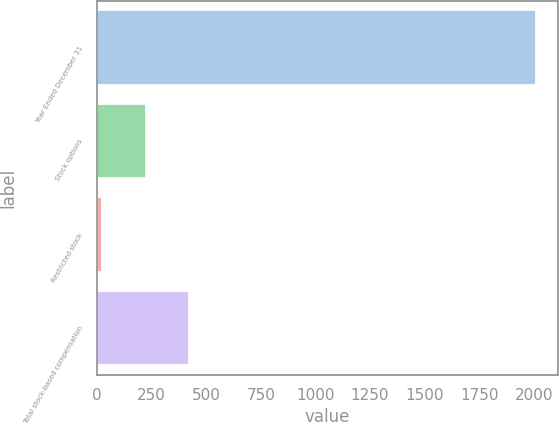Convert chart. <chart><loc_0><loc_0><loc_500><loc_500><bar_chart><fcel>Year Ended December 31<fcel>Stock options<fcel>Restricted stock<fcel>Total stock-based compensation<nl><fcel>2010<fcel>222.6<fcel>24<fcel>421.2<nl></chart> 